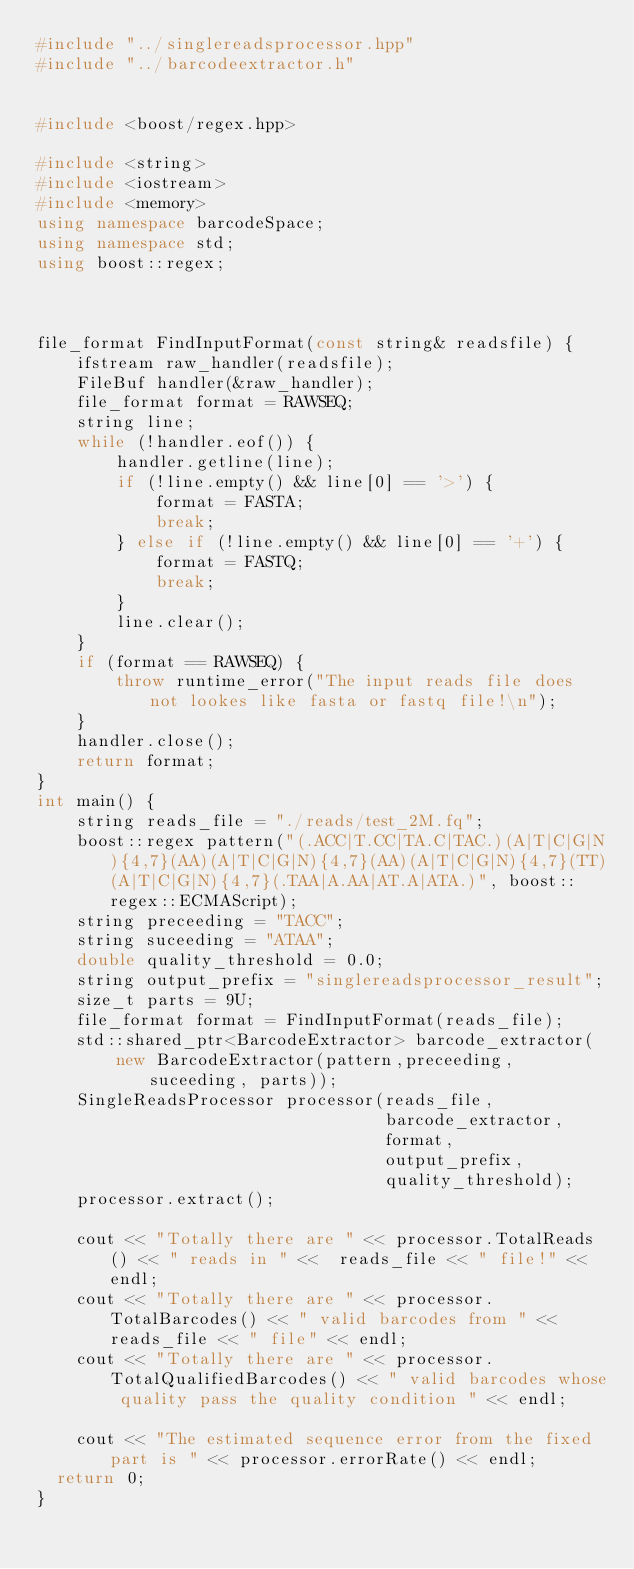<code> <loc_0><loc_0><loc_500><loc_500><_C++_>#include "../singlereadsprocessor.hpp"
#include "../barcodeextractor.h"


#include <boost/regex.hpp>

#include <string>
#include <iostream>
#include <memory>
using namespace barcodeSpace;
using namespace std;
using boost::regex;



file_format FindInputFormat(const string& readsfile) {
    ifstream raw_handler(readsfile);
    FileBuf handler(&raw_handler);
    file_format format = RAWSEQ;
    string line;
    while (!handler.eof()) {
        handler.getline(line);
        if (!line.empty() && line[0] == '>') {
            format = FASTA;
            break;
        } else if (!line.empty() && line[0] == '+') {
            format = FASTQ;
            break;
        }
        line.clear();
    }
    if (format == RAWSEQ) {
        throw runtime_error("The input reads file does not lookes like fasta or fastq file!\n");
    }
    handler.close();
    return format;
}
int main() {
    string reads_file = "./reads/test_2M.fq";
    boost::regex pattern("(.ACC|T.CC|TA.C|TAC.)(A|T|C|G|N){4,7}(AA)(A|T|C|G|N){4,7}(AA)(A|T|C|G|N){4,7}(TT)(A|T|C|G|N){4,7}(.TAA|A.AA|AT.A|ATA.)", boost::regex::ECMAScript);
    string preceeding = "TACC";
    string suceeding = "ATAA";
    double quality_threshold = 0.0;
    string output_prefix = "singlereadsprocessor_result";
    size_t parts = 9U;
    file_format format = FindInputFormat(reads_file);
    std::shared_ptr<BarcodeExtractor> barcode_extractor(
        new BarcodeExtractor(pattern,preceeding, suceeding, parts));
    SingleReadsProcessor processor(reads_file,
                                   barcode_extractor,
                                   format,
                                   output_prefix,
                                   quality_threshold);
    processor.extract();
    
    cout << "Totally there are " << processor.TotalReads() << " reads in " <<  reads_file << " file!" << endl;
    cout << "Totally there are " << processor.TotalBarcodes() << " valid barcodes from " << reads_file << " file" << endl;
    cout << "Totally there are " << processor.TotalQualifiedBarcodes() << " valid barcodes whose quality pass the quality condition " << endl;
    
    cout << "The estimated sequence error from the fixed part is " << processor.errorRate() << endl;	
	return 0;
}
</code> 